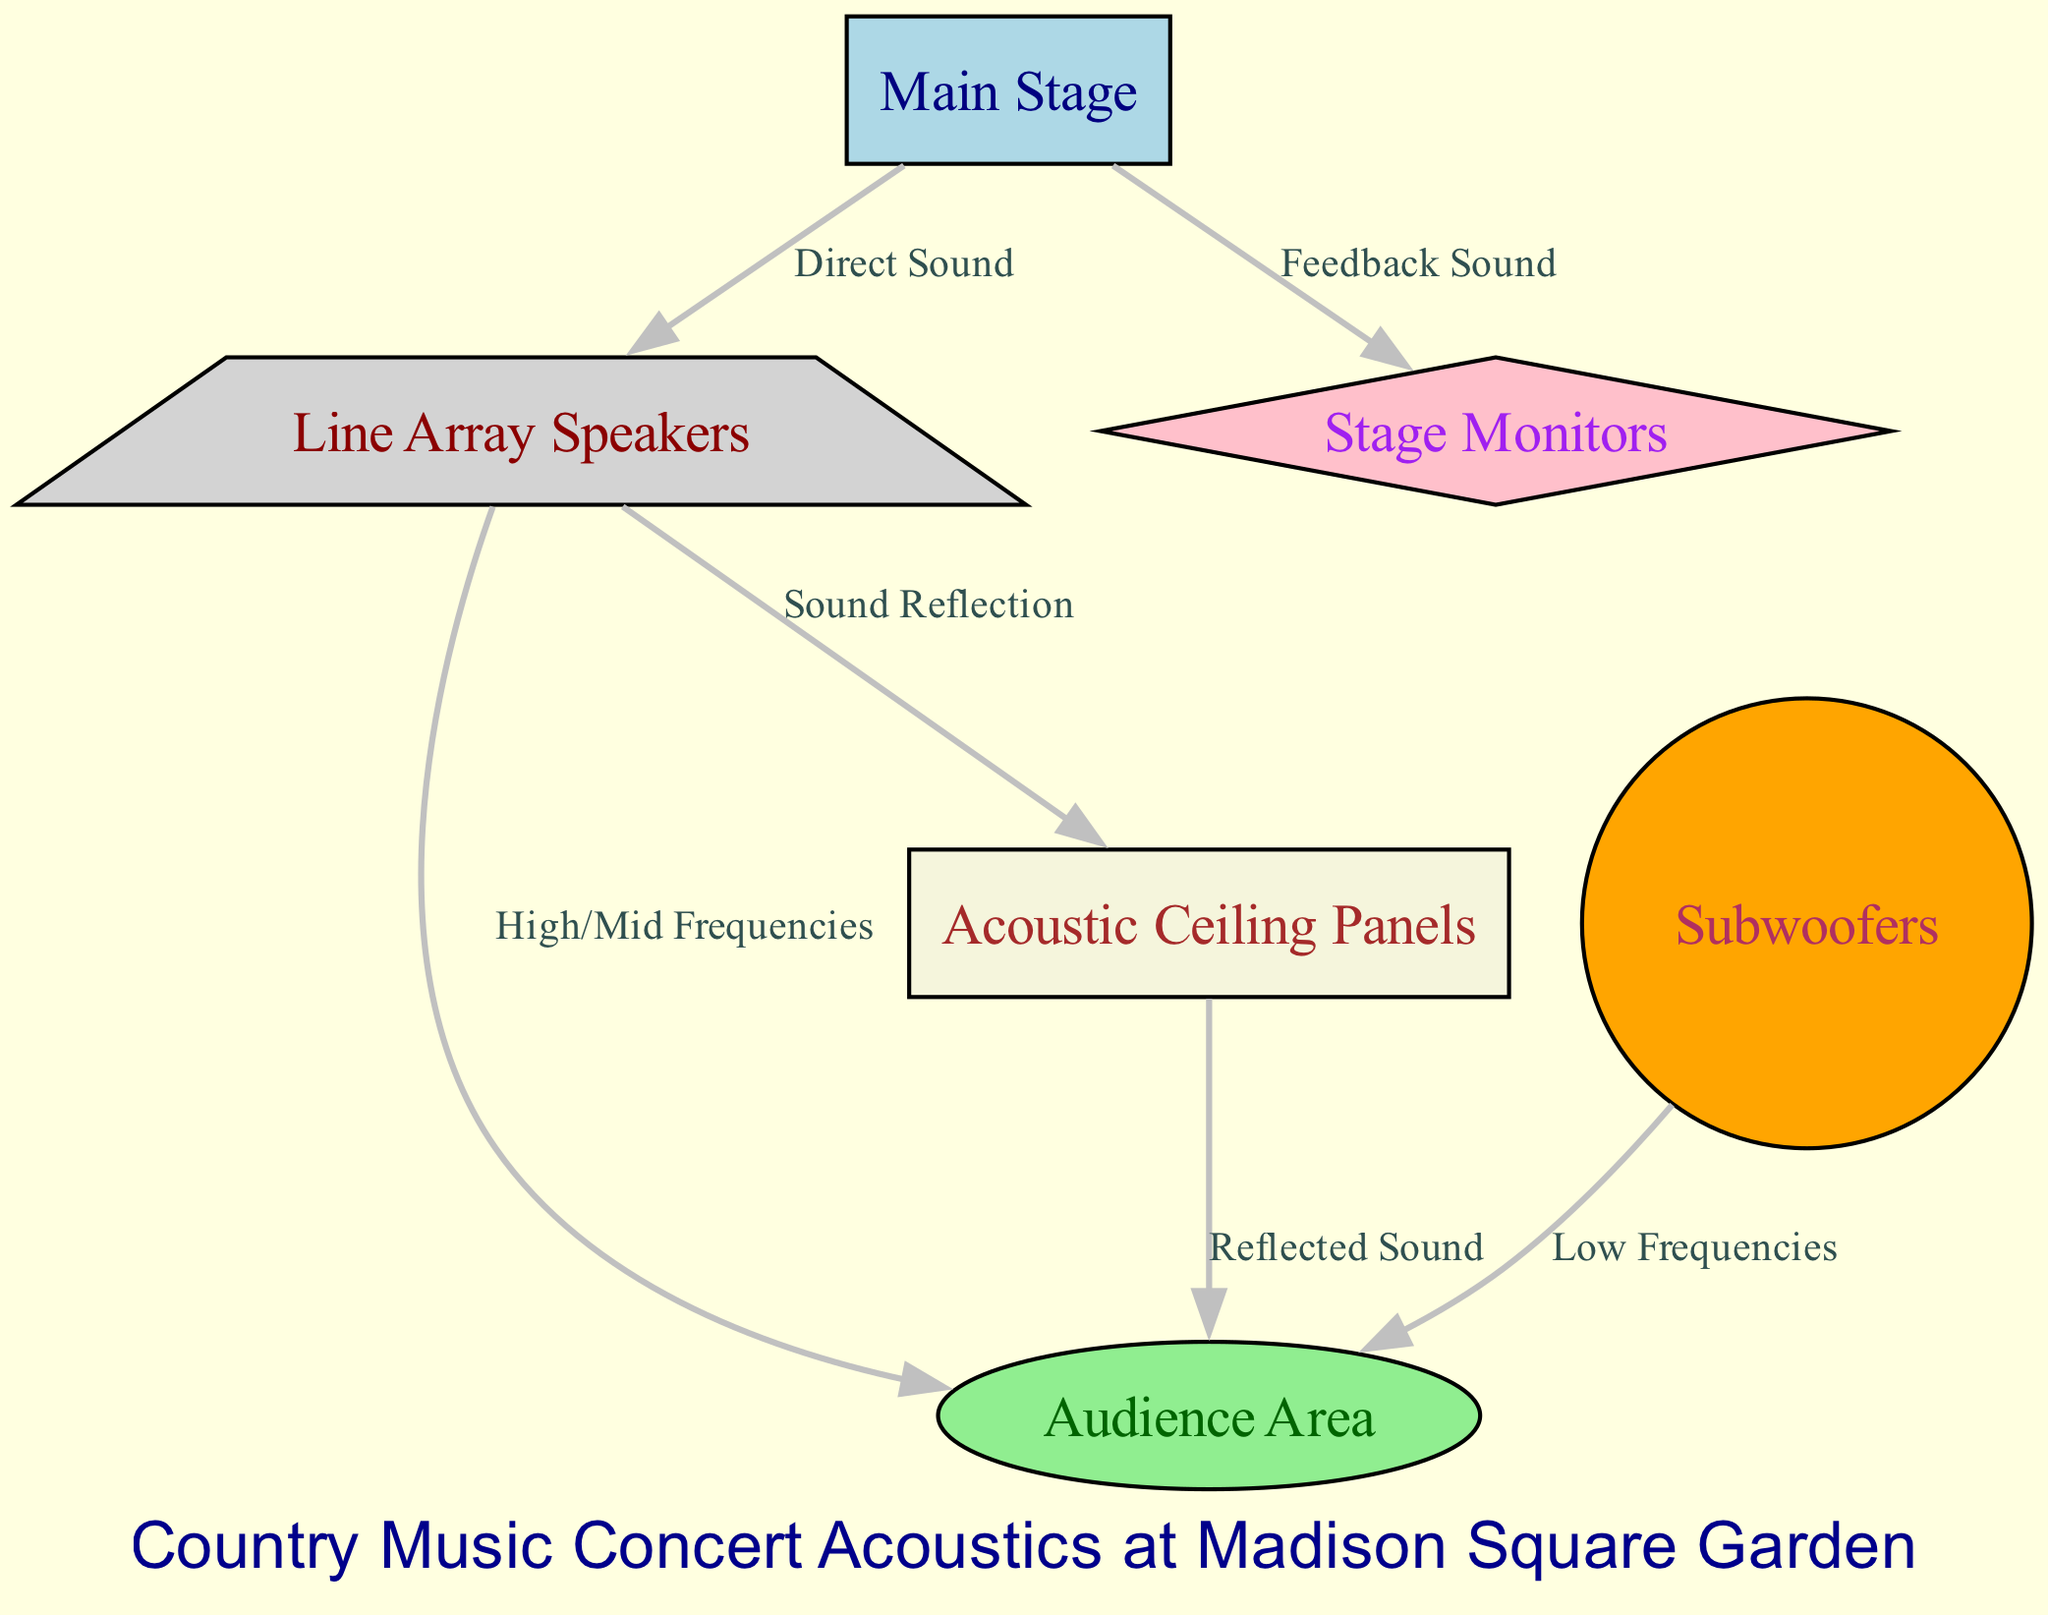What is the main source of sound in the diagram? The diagram shows "Main Stage" as the source of sound being directed via "Direct Sound" to "Line Array Speakers." Thus, the main source is the stage.
Answer: Main Stage How many edges are present in the diagram? The diagram lists connections, or edges, between nodes. There are a total of six edges connecting different components, as denoted by the lines between the nodes.
Answer: 6 What type of sound reaches the audience from the subwoofers? The diagram states that the subwoofers direct "Low Frequencies" to the audience area, highlighting the type of sound.
Answer: Low Frequencies Which node reflects sound to the audience? The diagram shows "Acoustic Ceiling Panels" reflecting sound labeled as "Reflected Sound" towards the "Audience Area," indicating they play a role in sound reflection.
Answer: Acoustic Ceiling Panels What is the role of stage monitors in the sound system? The diagram indicates that "Stage Monitors" receive "Feedback Sound" from the stage, suggesting they are used for the performers to hear themselves and stay in sync.
Answer: Feedback Sound Which nodes are involved in the transmission of high/mid frequencies? According to the diagram, "Line Array Speakers" are responsible for transmitting "High/Mid Frequencies" from the stage to the audience area, showcasing their importance in sound frequency transmission.
Answer: Line Array Speakers What type of structure is used for creating feedback sound? The diagram illustrates that "Stage Monitors" are where "Feedback Sound" originates, indicating that they are crucial for capturing this specific sound type.
Answer: Stage Monitors How does sound travel from speakers to the audience? The diagram indicates that sound travels from "Line Array Speakers" to the "Audience Area" through high/mid frequencies, demonstrating the direct route for sound delivery.
Answer: High/Mid Frequencies What is the purpose of the acoustic ceiling panels in this setup? The diagram shows that "Acoustic Ceiling Panels" reflect sound toward the audience, suggesting they are used to manage and enhance sound quality in the venue.
Answer: Reflect sound 